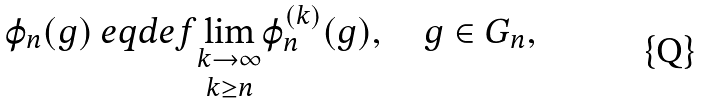<formula> <loc_0><loc_0><loc_500><loc_500>\varphi _ { n } ( g ) \ e q d e f \underset { k \geq n } { \lim _ { k \to \infty } } \varphi _ { n } ^ { ( k ) } ( g ) , \quad g \in G _ { n } ,</formula> 